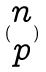<formula> <loc_0><loc_0><loc_500><loc_500>( \begin{matrix} n \\ p \end{matrix} )</formula> 